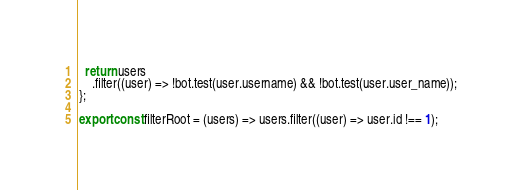Convert code to text. <code><loc_0><loc_0><loc_500><loc_500><_JavaScript_>  return users
    .filter((user) => !bot.test(user.username) && !bot.test(user.user_name));
};

export const filterRoot = (users) => users.filter((user) => user.id !== 1);
</code> 